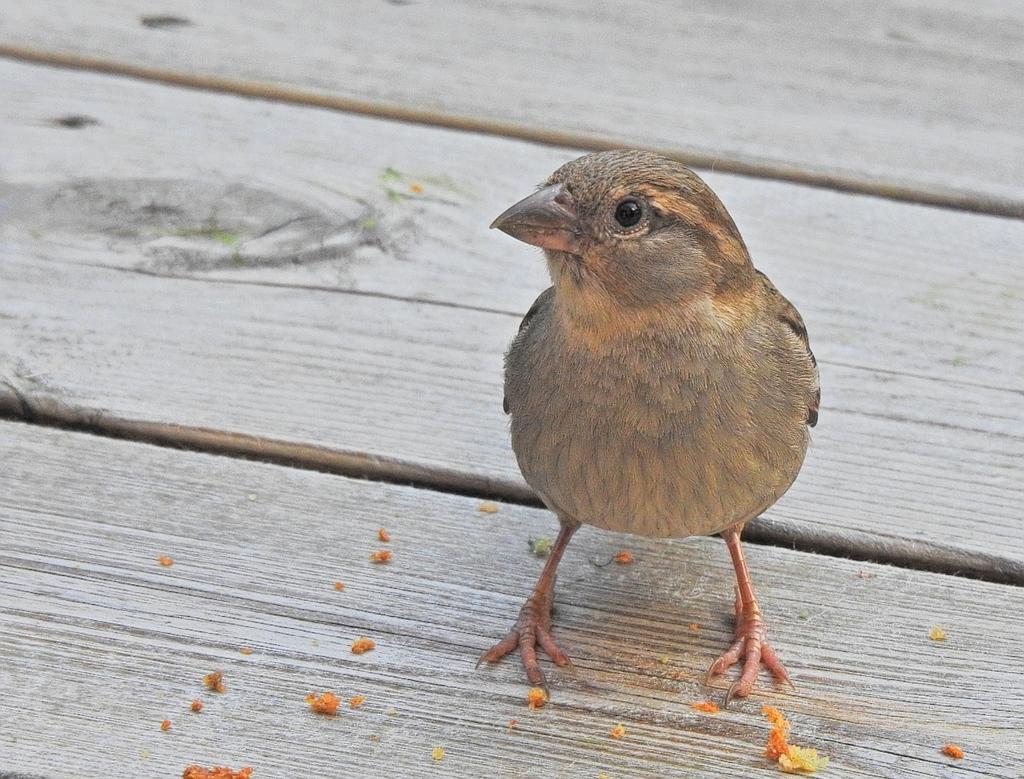Please provide a concise description of this image. In this image we can see a bird on the wooden table, it is in brown color. 